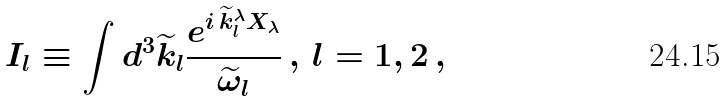<formula> <loc_0><loc_0><loc_500><loc_500>I _ { l } \equiv \int d ^ { 3 } \widetilde { k } _ { l } \frac { e ^ { i \, \widetilde { k } _ { l } ^ { \lambda } X _ { \lambda } } } { \widetilde { \omega } _ { l } } \, , \, l = 1 , 2 \, ,</formula> 